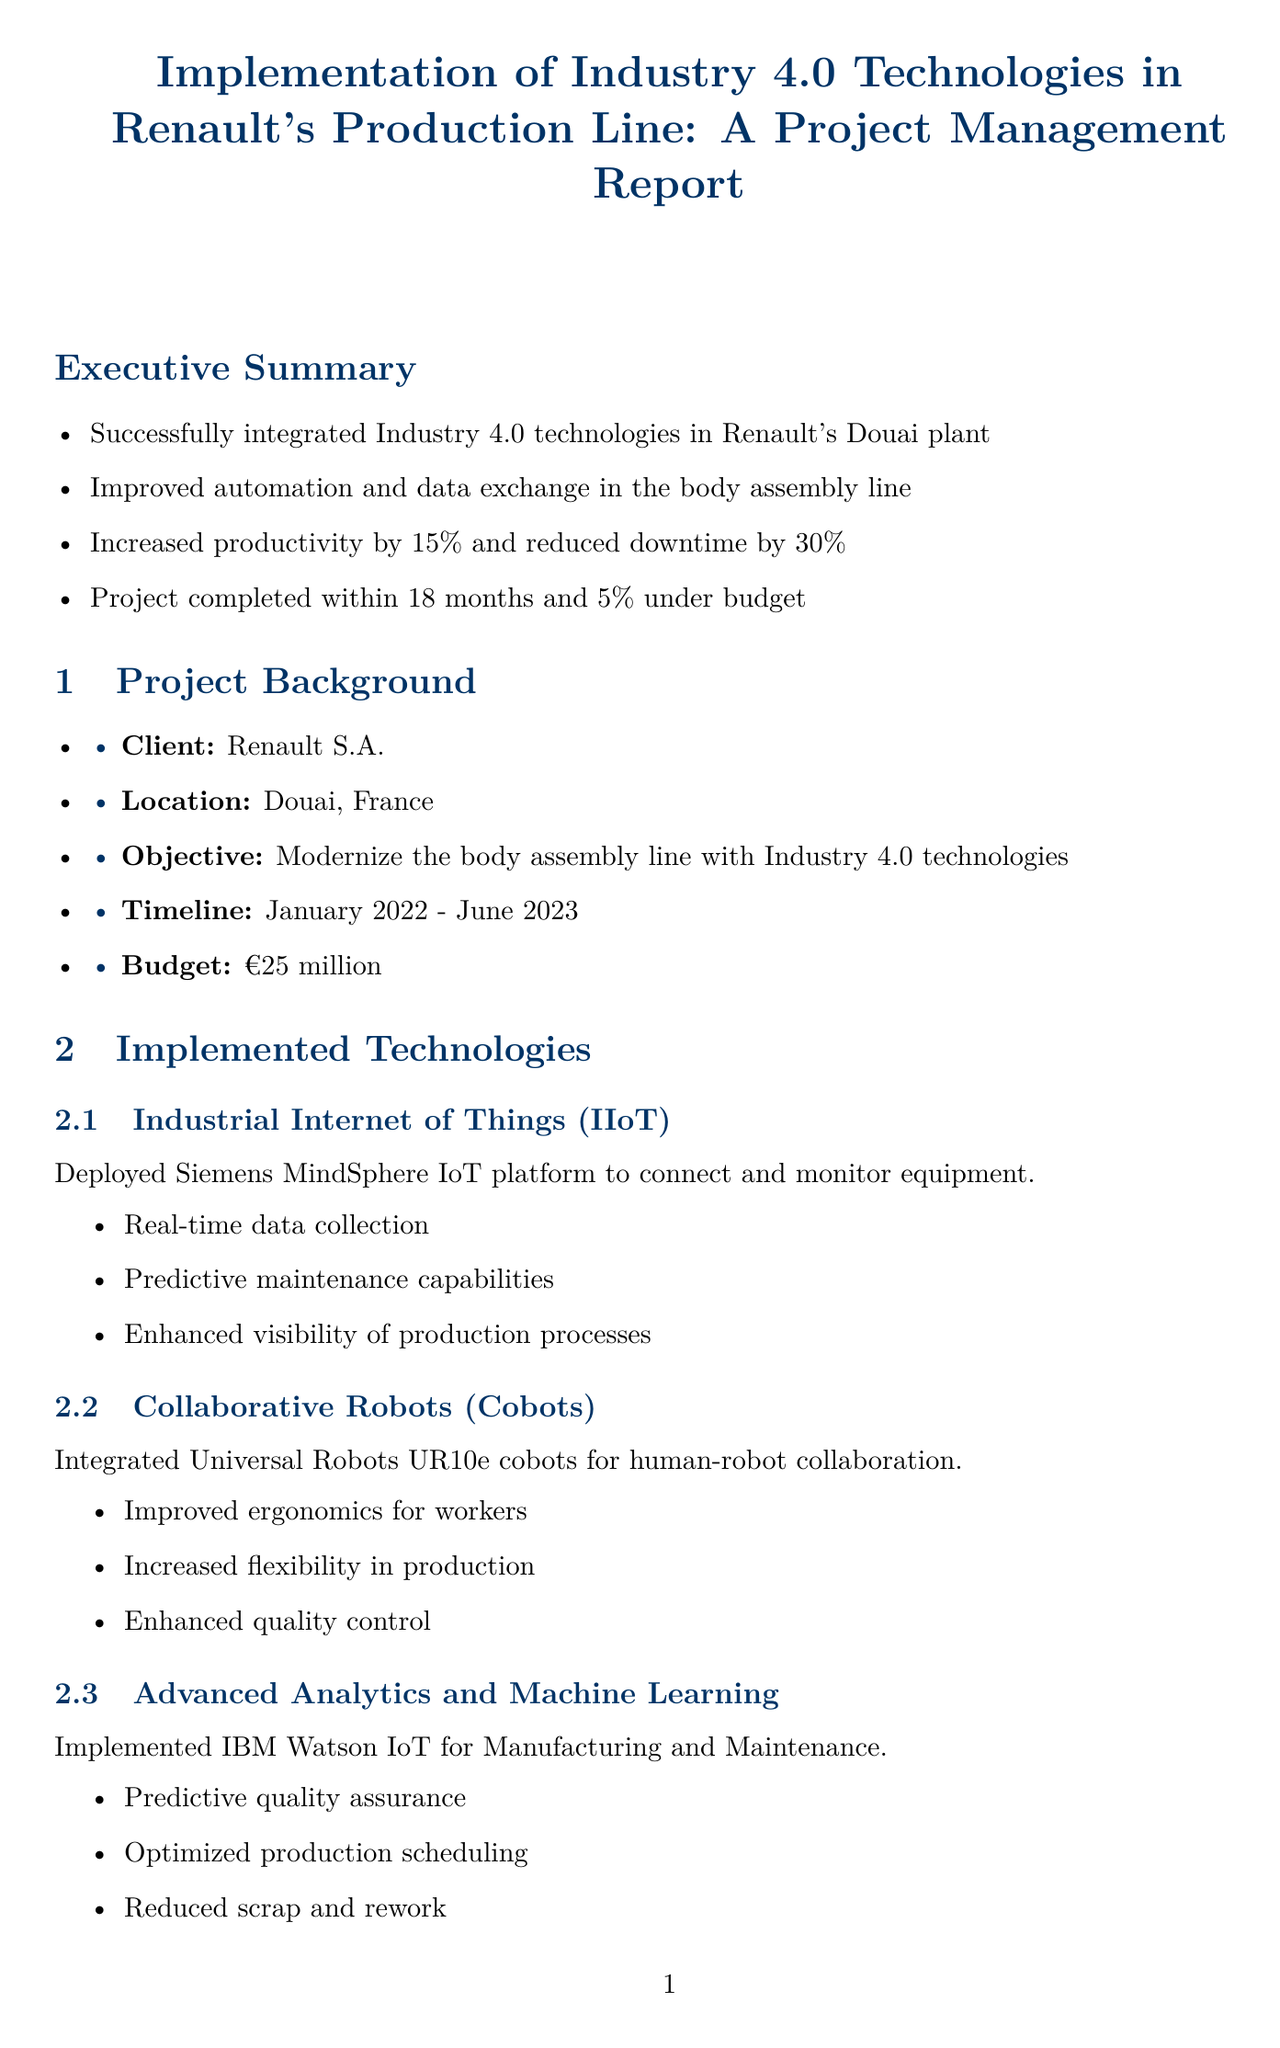What was the budget for the project? The budget for the project is explicitly mentioned in the document as €25 million.
Answer: €25 million What is the location of the client's production line? The document states that the client's production line is located in Douai, France.
Answer: Douai, France How much did productivity increase after the implementation? The report indicates that productivity increased by 15% due to the project.
Answer: 15% What challenge was related to employee adaptation? The document highlights the challenge of employee resistance to new technologies during the project.
Answer: Employee resistance to new technologies Which technology was used for predictive maintenance? The implemented technology for predictive maintenance is the Siemens MindSphere IoT platform.
Answer: Siemens MindSphere IoT platform What was the improvement in Overall Equipment Effectiveness (OEE)? The document states that the OEE improved from 72% to 85%.
Answer: Increased from 72% to 85% What is one future recommendation presented in the report? One future recommendation is to expand the implementation to other production lines within the Douai plant.
Answer: Expand implementation to other production lines within the Douai plant What was the timeline for project completion? The timeline for the project is mentioned as January 2022 to June 2023.
Answer: January 2022 - June 2023 What software was used for quality management? The report specifies that Siemens Opcenter Quality software was deployed for quality management.
Answer: Siemens Opcenter Quality software 